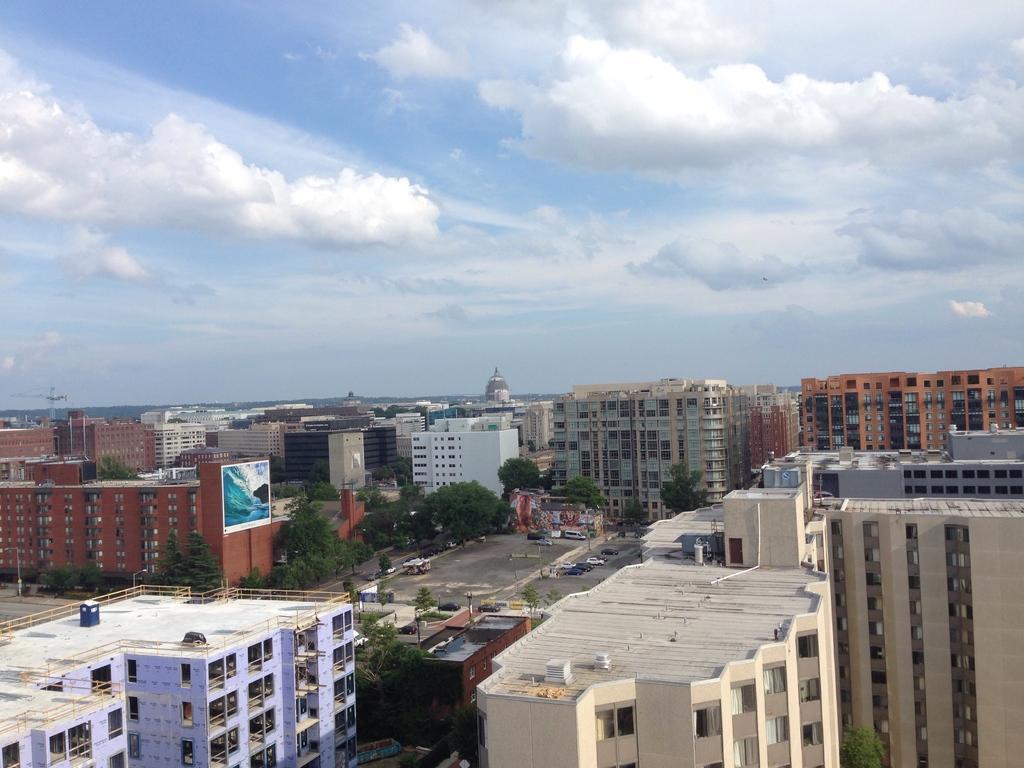How would you summarize this image in a sentence or two? In this picture we can see a few buildings from left to right. We can a poster on a brown building. There are a few vehicles, poles and trees are visible on the path. Sky is blue in color and cloudy. 